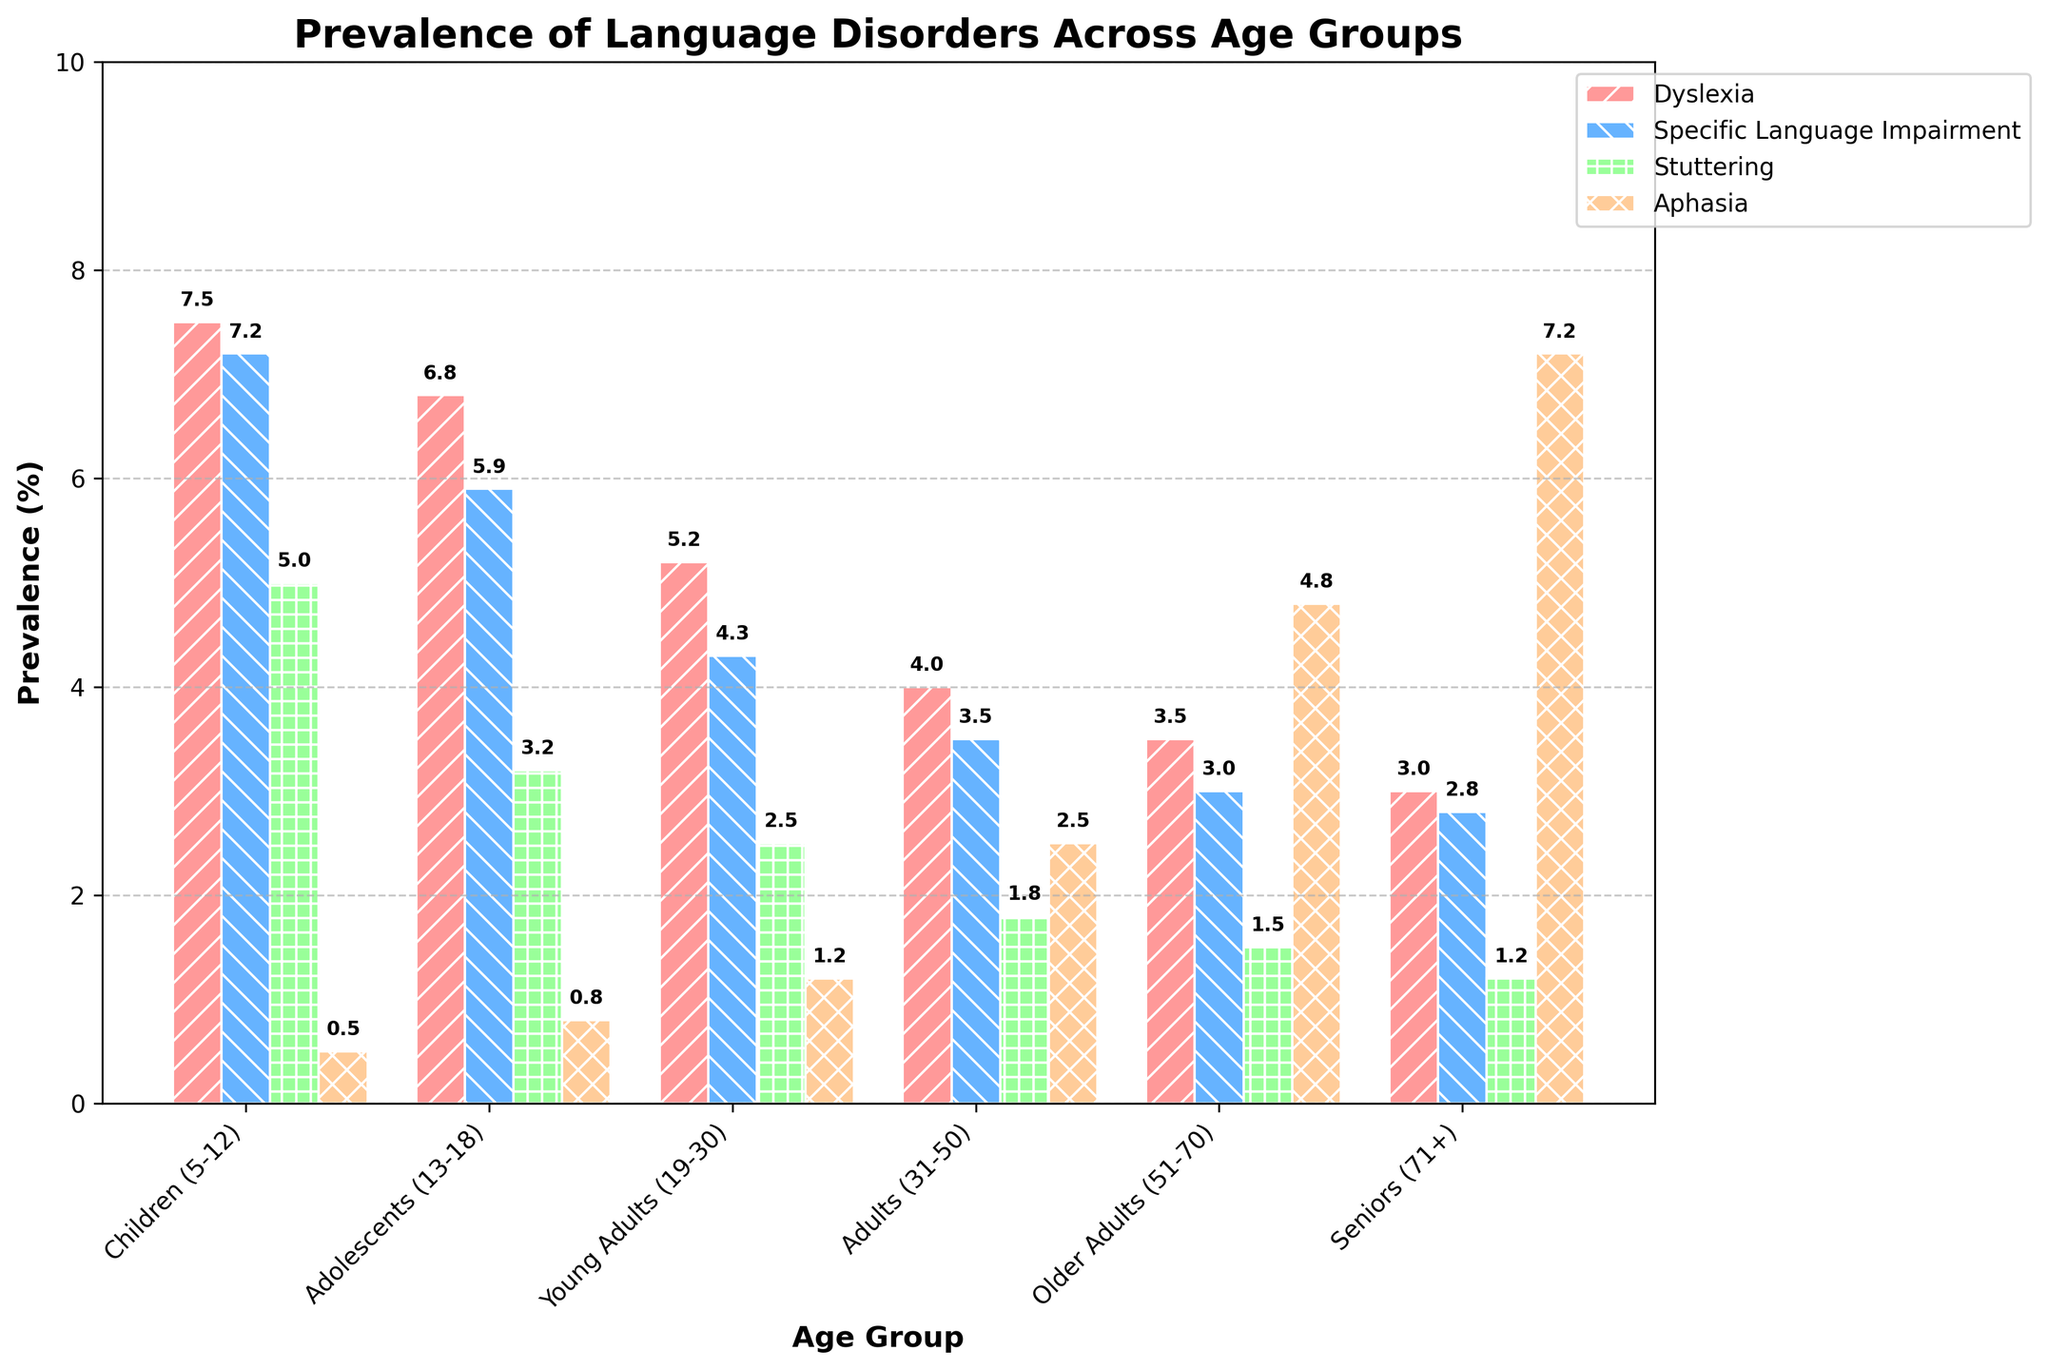What is the prevalence of Dyslexia in Adolescents (13-18) compared to Adults (31-50)? To determine the difference, identify the prevalence values for both age groups. Dyslexia prevalence in Adolescents is 6.8%, while in Adults it is 4.0%. Therefore, Adolescents have a higher prevalence by subtracting the Adult value from the Adolescent value: 6.8% - 4.0% = 2.8%.
Answer: 2.8% Which age group has the highest prevalence of Aphasia? Look at the heights of the bars representing Aphasia across all age groups and identify the tallest bar. The Seniors (71+) group has the tallest Aphasia bar at 7.2%.
Answer: Seniors (71+) What's the average prevalence of Specific Language Impairment across all age groups? Add up the Specific Language Impairment percentages for all age groups and divide by the number of age groups. (7.2 + 5.9 + 4.3 + 3.5 + 3.0 + 2.8) / 6 = 26.7 / 6 ≈ 4.45%.
Answer: 4.45% Among the given language disorders, which has the lowest overall prevalence in Young Adults (19-30)? Refer to the bars representing the disorders in the Young Adults group and identify the lowest value. The lowest is Stuttering at 2.5%.
Answer: Stuttering What is the difference in prevalence of Stuttering between Children (5-12) and Older Adults (51-70)? Find the prevalence values for Stuttering in both age groups. Children have a 5.0% prevalence, while Older Adults have 1.5%. Subtract the Older Adults value from the Children value: 5.0% - 1.5% = 3.5%.
Answer: 3.5% Which disorder shows the greatest increase in prevalence from Young Adults (19-30) to Seniors (71+)? Examine the prevalence percentages for each disorder in both age groups and calculate the differences. The greatest increase is Aphasia, which goes from 1.2% in Young Adults to 7.2% in Seniors, an increase of 6.0%.
Answer: Aphasia Among Adolescents (13-18), which language disorder is closest in prevalence to Specific Language Impairment? Compare the prevalence values for language disorders in Adolescents. Specific Language Impairment is at 5.9%, and Dyslexia is the closest with 6.8%.
Answer: Dyslexia How many age groups have a Stuttering prevalence of 3% or higher? Count the groups where the Stuttering prevalence bar height reaches or exceeds 3%. These groups are Children (5.0%), Adolescents (3.2%), and Young Adults (2.5%). Therefore, there are 2 such groups.
Answer: 2 What's the total prevalence percentage for Aphasia across all age groups? Add the Aphasia percentages for every age group. 0.5 + 0.8 + 1.2 + 2.5 + 4.8 + 7.2 = 17.0%.
Answer: 17.0% Which disorder’s prevalence decreases the most from Children (5-12) to Adults (31-50)? Calculate the difference for each disorder between these age groups. The decreases are as follows: Dyslexia (7.5% to 4.0%, decrease of 3.5%), Specific Language Impairment (7.2% to 3.5%, decrease of 3.7%), Stuttering (5.0% to 1.8%, decrease of 3.2%), Aphasia (0.5% to 2.5%, increase of 2.0%). The greatest decrease is in Specific Language Impairment.
Answer: Specific Language Impairment 